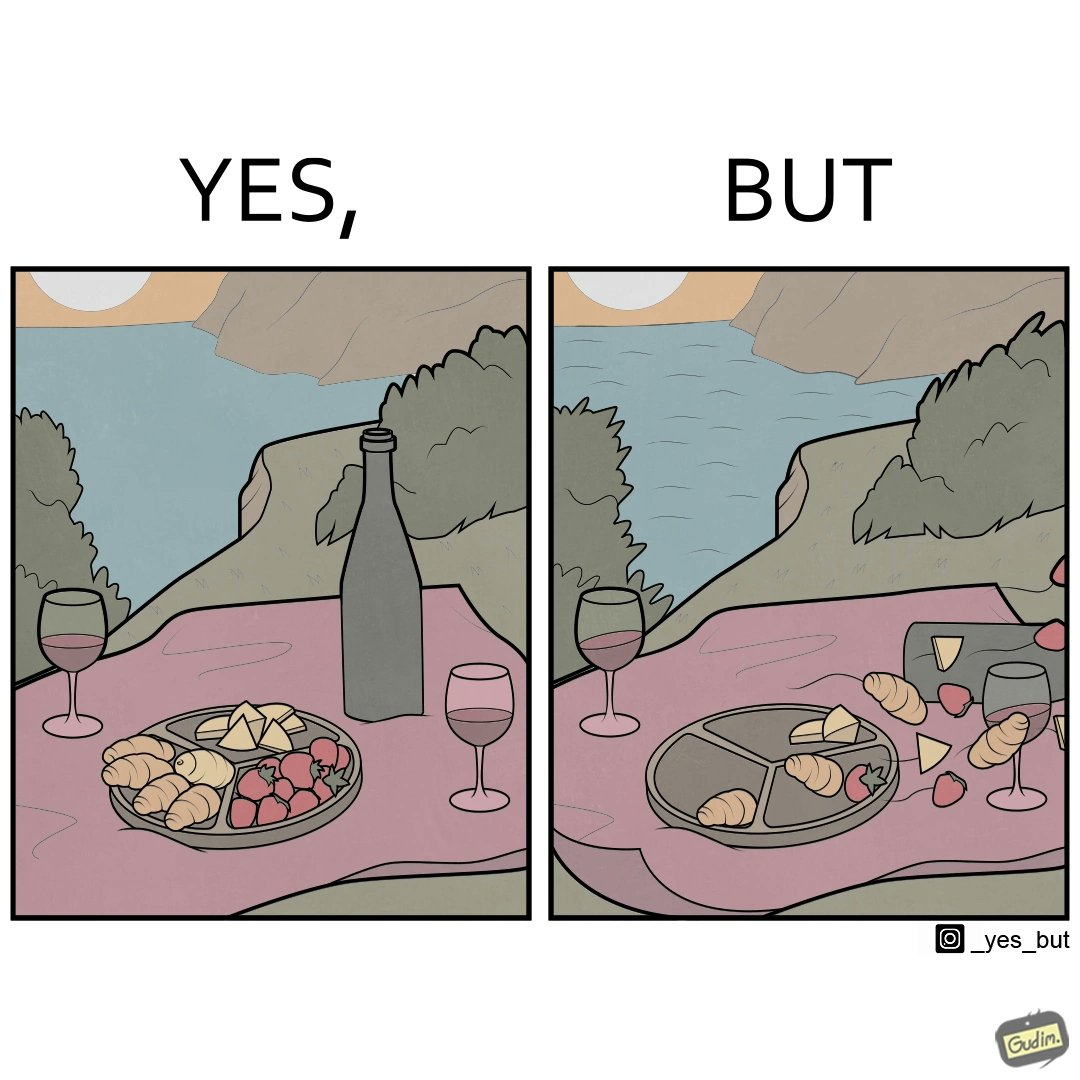What do you see in each half of this image? In the left part of the image: The food is in the plate. In the right part of the image: The food is flying. 